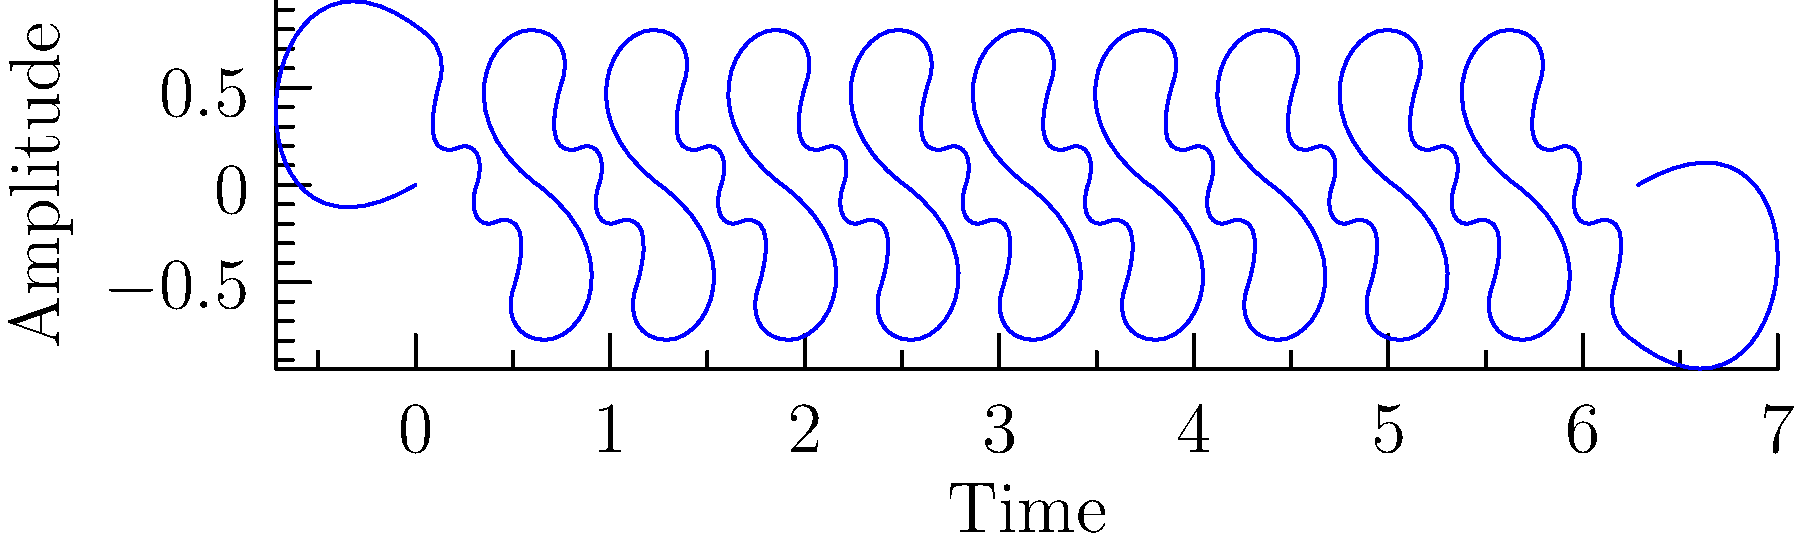As a Cranberries fan, you might be familiar with their distinctive sound. Looking at this waveform visualization, which genre do you think this song most likely belongs to?

a) Classical
b) Rock
c) Electronic Dance Music (EDM)
d) Jazz To determine the genre from the waveform, let's analyze its characteristics step-by-step:

1. Complexity: The waveform shows a complex pattern with multiple frequencies overlapping, indicating a rich harmonic content.

2. Regularity: There's a repeating pattern, but it's not perfectly uniform, suggesting the presence of instruments and possibly vocals.

3. Amplitude variation: The waveform has moderate amplitude variations, which is typical for rock music with its dynamic range of loud and soft parts.

4. Density: The waveform is relatively dense, indicating multiple instruments playing simultaneously, which is common in rock music.

5. Lack of extreme peaks or drops: Unlike EDM, there are no sudden, extreme changes in amplitude that would indicate heavy bass drops or electronic effects.

6. Comparison to known genres:
   - Classical music typically has more dramatic amplitude changes and clearer separations between instruments.
   - Jazz would likely show more irregular patterns due to improvisation.
   - EDM would have more uniform, repetitive patterns and sudden amplitude changes.

7. Similarity to rock: The overall pattern is most consistent with rock music, which often features guitars, drums, and vocals creating a complex but relatively consistent waveform.

Given these observations and your familiarity with The Cranberries' rock sound, this waveform most likely represents a rock song.
Answer: b) Rock 